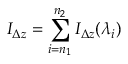<formula> <loc_0><loc_0><loc_500><loc_500>I _ { \Delta z } = \sum _ { i = n _ { 1 } } ^ { n _ { 2 } } { I _ { \Delta z } ( \lambda _ { i } ) }</formula> 